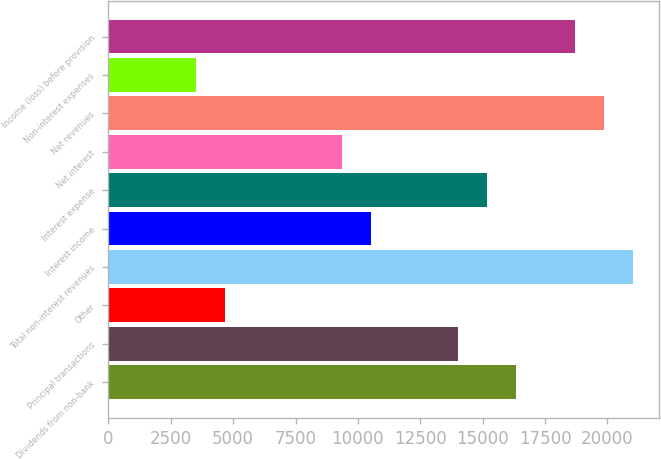Convert chart. <chart><loc_0><loc_0><loc_500><loc_500><bar_chart><fcel>Dividends from non-bank<fcel>Principal transactions<fcel>Other<fcel>Total non-interest revenues<fcel>Interest income<fcel>Interest expense<fcel>Net interest<fcel>Net revenues<fcel>Non-interest expenses<fcel>Income (loss) before provision<nl><fcel>16354.8<fcel>14019.4<fcel>4677.8<fcel>21025.6<fcel>10516.3<fcel>15187.1<fcel>9348.6<fcel>19857.9<fcel>3510.1<fcel>18690.2<nl></chart> 